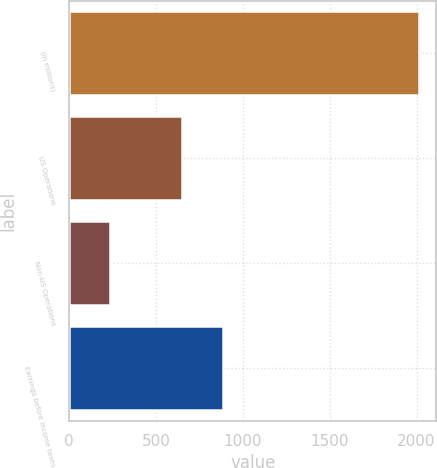<chart> <loc_0><loc_0><loc_500><loc_500><bar_chart><fcel>(in millions)<fcel>US Operations<fcel>Non-US Operations<fcel>Earnings before income taxes<nl><fcel>2013<fcel>651<fcel>237<fcel>888<nl></chart> 